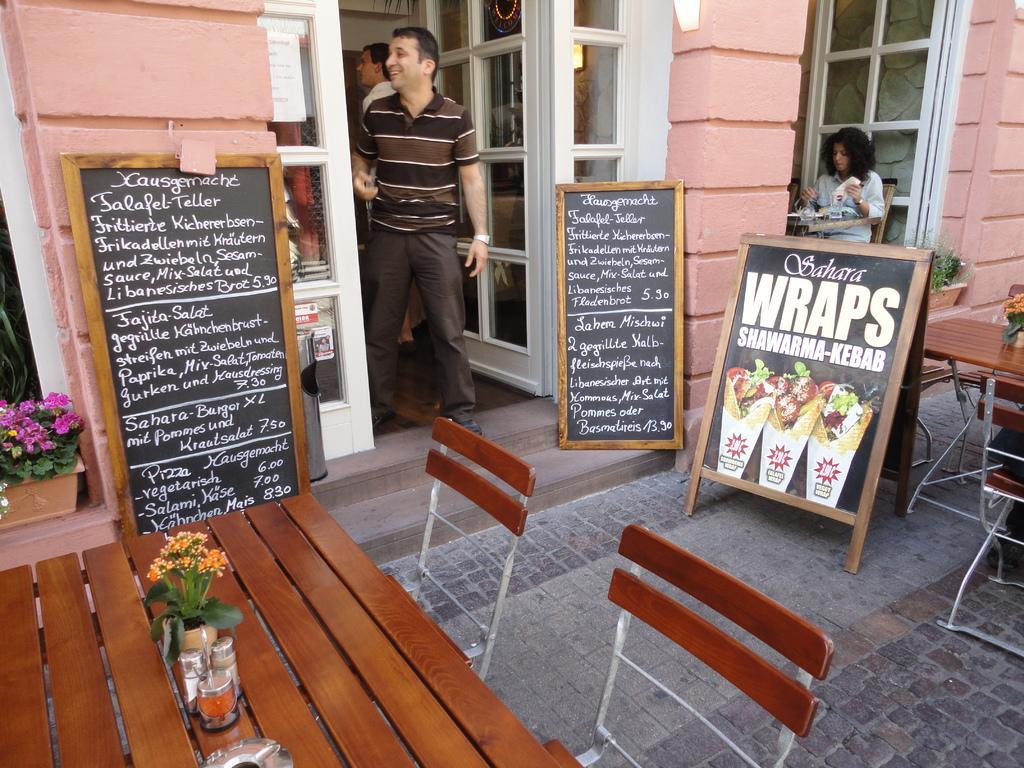In one or two sentences, can you explain what this image depicts? There are two blackboards which has something written on it and there is a person standing in between them and there is a table and chairs in left and right corners. 